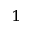<formula> <loc_0><loc_0><loc_500><loc_500>^ { 1 }</formula> 